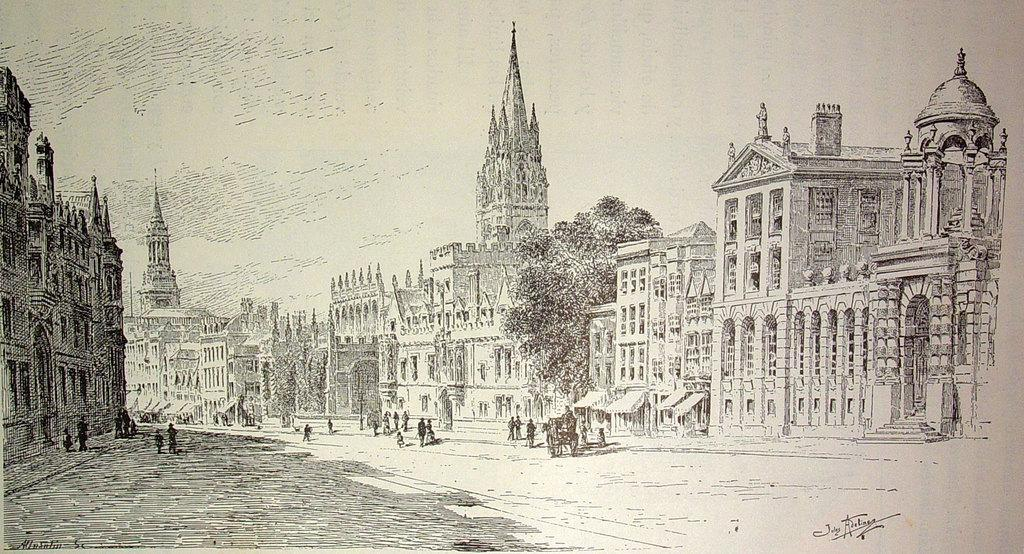What type of structures can be seen in the image? There are buildings in the image. What type of natural elements are present in the image? There are trees in the image. What type of living organisms can be seen in the image? There are persons in the image. What type of bread can be seen in the image? There is no bread present in the image. What is the tendency of the stream in the image? There is no stream present in the image. 